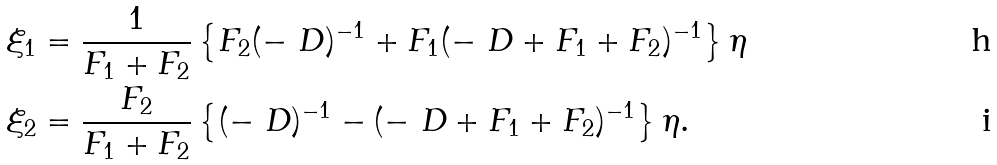<formula> <loc_0><loc_0><loc_500><loc_500>\xi _ { 1 } & = \frac { 1 } { F _ { 1 } + F _ { 2 } } \left \{ F _ { 2 } ( - \ D ) ^ { - 1 } + F _ { 1 } ( - \ D + F _ { 1 } + F _ { 2 } ) ^ { - 1 } \right \} \eta \\ \xi _ { 2 } & = \frac { F _ { 2 } } { F _ { 1 } + F _ { 2 } } \left \{ ( - \ D ) ^ { - 1 } - ( - \ D + F _ { 1 } + F _ { 2 } ) ^ { - 1 } \right \} \eta .</formula> 